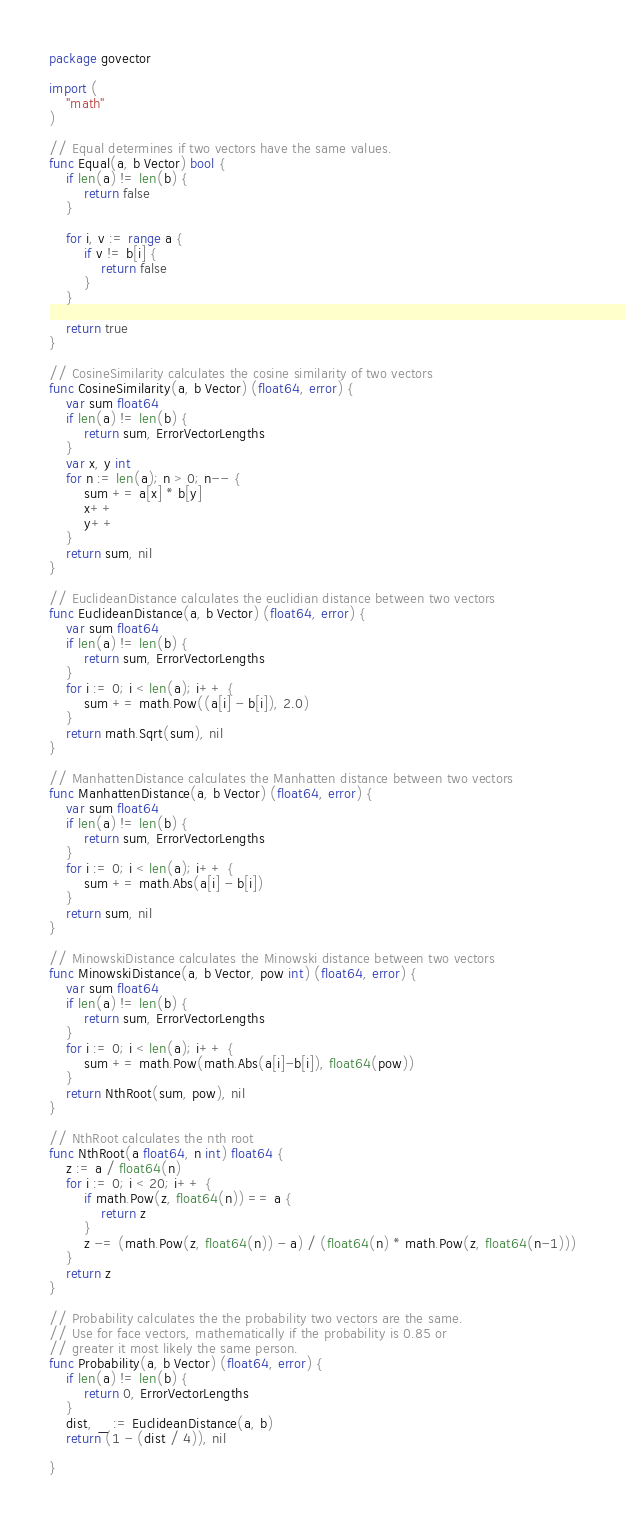Convert code to text. <code><loc_0><loc_0><loc_500><loc_500><_Go_>package govector

import (
	"math"
)

// Equal determines if two vectors have the same values.
func Equal(a, b Vector) bool {
	if len(a) != len(b) {
		return false
	}

	for i, v := range a {
		if v != b[i] {
			return false
		}
	}

	return true
}

// CosineSimilarity calculates the cosine similarity of two vectors
func CosineSimilarity(a, b Vector) (float64, error) {
	var sum float64
	if len(a) != len(b) {
		return sum, ErrorVectorLengths
	}
	var x, y int
	for n := len(a); n > 0; n-- {
		sum += a[x] * b[y]
		x++
		y++
	}
	return sum, nil
}

// EuclideanDistance calculates the euclidian distance between two vectors
func EuclideanDistance(a, b Vector) (float64, error) {
	var sum float64
	if len(a) != len(b) {
		return sum, ErrorVectorLengths
	}
	for i := 0; i < len(a); i++ {
		sum += math.Pow((a[i] - b[i]), 2.0)
	}
	return math.Sqrt(sum), nil
}

// ManhattenDistance calculates the Manhatten distance between two vectors
func ManhattenDistance(a, b Vector) (float64, error) {
	var sum float64
	if len(a) != len(b) {
		return sum, ErrorVectorLengths
	}
	for i := 0; i < len(a); i++ {
		sum += math.Abs(a[i] - b[i])
	}
	return sum, nil
}

// MinowskiDistance calculates the Minowski distance between two vectors
func MinowskiDistance(a, b Vector, pow int) (float64, error) {
	var sum float64
	if len(a) != len(b) {
		return sum, ErrorVectorLengths
	}
	for i := 0; i < len(a); i++ {
		sum += math.Pow(math.Abs(a[i]-b[i]), float64(pow))
	}
	return NthRoot(sum, pow), nil
}

// NthRoot calculates the nth root
func NthRoot(a float64, n int) float64 {
	z := a / float64(n)
	for i := 0; i < 20; i++ {
		if math.Pow(z, float64(n)) == a {
			return z
		}
		z -= (math.Pow(z, float64(n)) - a) / (float64(n) * math.Pow(z, float64(n-1)))
	}
	return z
}

// Probability calculates the the probability two vectors are the same.
// Use for face vectors, mathematically if the probability is 0.85 or
// greater it most likely the same person.
func Probability(a, b Vector) (float64, error) {
	if len(a) != len(b) {
		return 0, ErrorVectorLengths
	}
	dist, _ := EuclideanDistance(a, b)
	return (1 - (dist / 4)), nil

}
</code> 